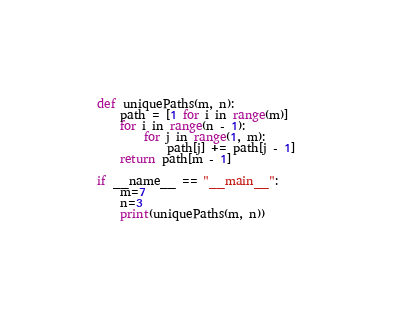Convert code to text. <code><loc_0><loc_0><loc_500><loc_500><_Python_>def uniquePaths(m, n):
    path = [1 for i in range(m)]
    for i in range(n - 1): 
        for j in range(1, m):  
            path[j] += path[j - 1] 
    return path[m - 1]
 
if __name__ == "__main__":
    m=7
    n=3
    print(uniquePaths(m, n))</code> 